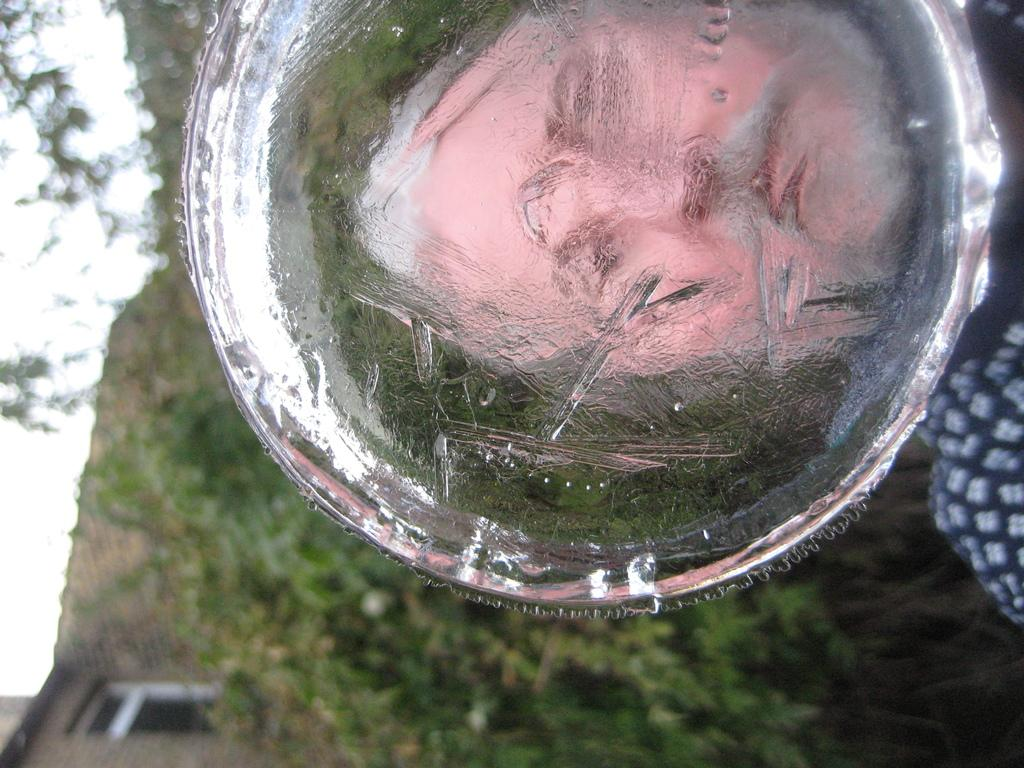What is reflected on the ice in the image? There is a woman's face reflected on the ice. What type of natural environment can be seen in the image? There are trees visible in the image. What type of structure is present in the image? There is a house with a window in the image. What is visible in the background of the image? The sky is visible in the image. What color of paint is being used by the ladybug in the image? There is no ladybug present in the image, and therefore no paint can be associated with it. 